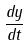Convert formula to latex. <formula><loc_0><loc_0><loc_500><loc_500>\frac { d y } { d t }</formula> 